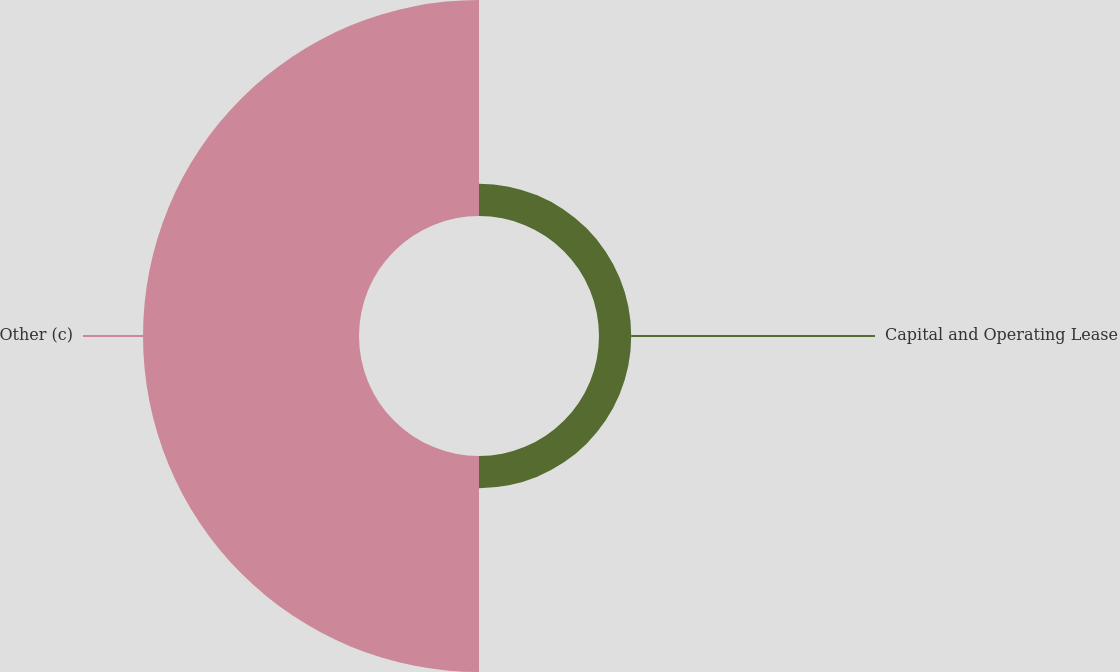Convert chart. <chart><loc_0><loc_0><loc_500><loc_500><pie_chart><fcel>Capital and Operating Lease<fcel>Other (c)<nl><fcel>12.98%<fcel>87.02%<nl></chart> 